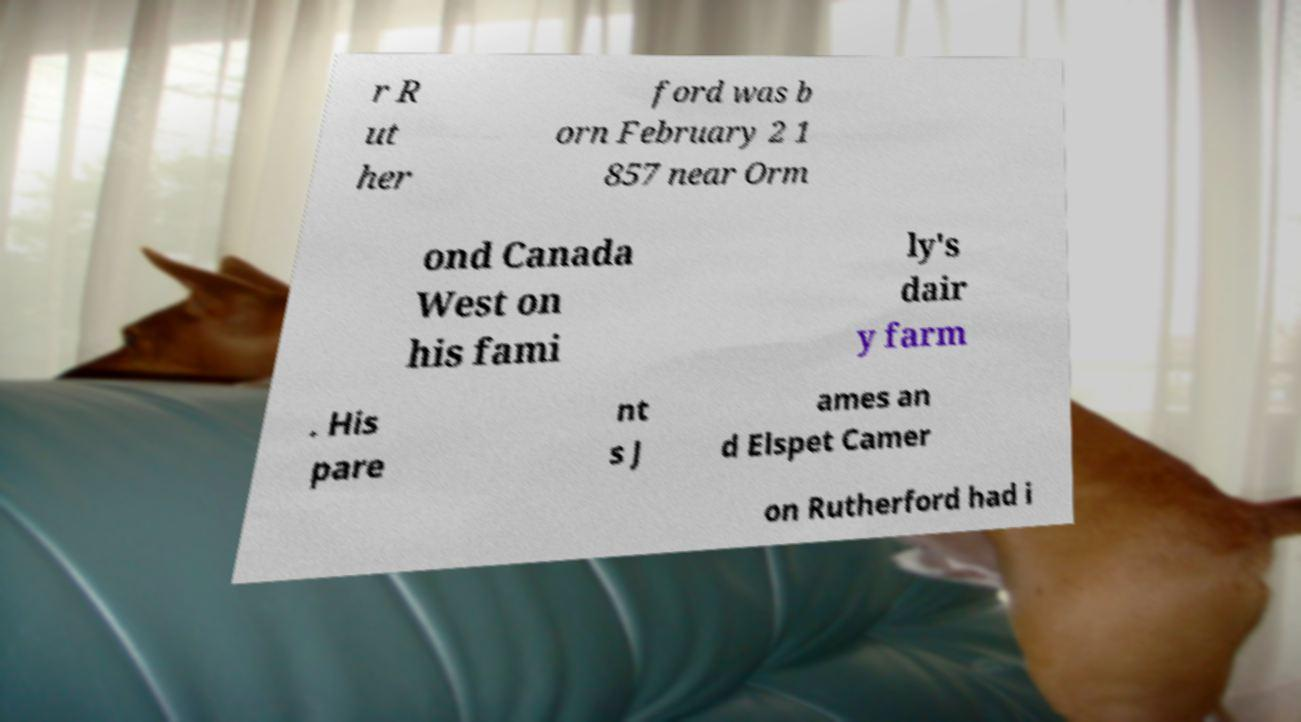What messages or text are displayed in this image? I need them in a readable, typed format. r R ut her ford was b orn February 2 1 857 near Orm ond Canada West on his fami ly's dair y farm . His pare nt s J ames an d Elspet Camer on Rutherford had i 